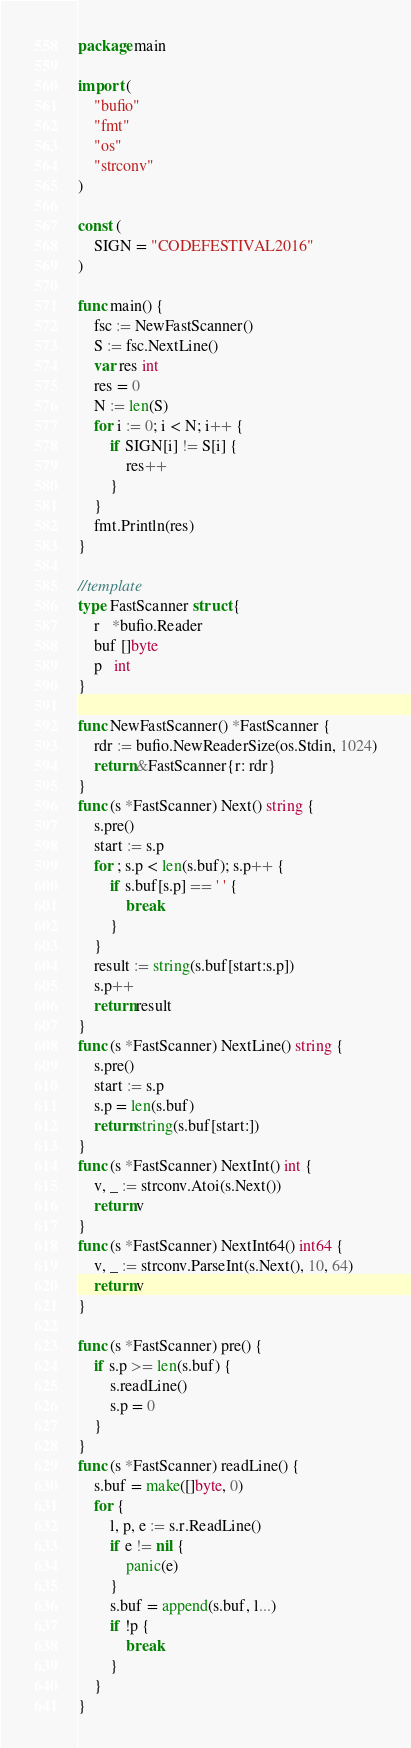Convert code to text. <code><loc_0><loc_0><loc_500><loc_500><_Go_>package main

import (
	"bufio"
	"fmt"
	"os"
	"strconv"
)

const (
	SIGN = "CODEFESTIVAL2016"
)

func main() {
	fsc := NewFastScanner()
	S := fsc.NextLine()
	var res int
	res = 0
	N := len(S)
	for i := 0; i < N; i++ {
		if SIGN[i] != S[i] {
			res++
		}
	}
	fmt.Println(res)
}

//template
type FastScanner struct {
	r   *bufio.Reader
	buf []byte
	p   int
}

func NewFastScanner() *FastScanner {
	rdr := bufio.NewReaderSize(os.Stdin, 1024)
	return &FastScanner{r: rdr}
}
func (s *FastScanner) Next() string {
	s.pre()
	start := s.p
	for ; s.p < len(s.buf); s.p++ {
		if s.buf[s.p] == ' ' {
			break
		}
	}
	result := string(s.buf[start:s.p])
	s.p++
	return result
}
func (s *FastScanner) NextLine() string {
	s.pre()
	start := s.p
	s.p = len(s.buf)
	return string(s.buf[start:])
}
func (s *FastScanner) NextInt() int {
	v, _ := strconv.Atoi(s.Next())
	return v
}
func (s *FastScanner) NextInt64() int64 {
	v, _ := strconv.ParseInt(s.Next(), 10, 64)
	return v
}

func (s *FastScanner) pre() {
	if s.p >= len(s.buf) {
		s.readLine()
		s.p = 0
	}
}
func (s *FastScanner) readLine() {
	s.buf = make([]byte, 0)
	for {
		l, p, e := s.r.ReadLine()
		if e != nil {
			panic(e)
		}
		s.buf = append(s.buf, l...)
		if !p {
			break
		}
	}
}
</code> 